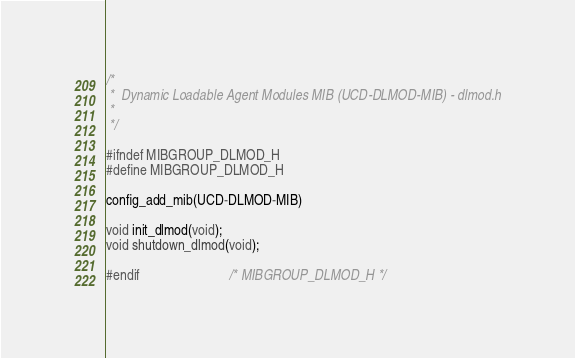Convert code to text. <code><loc_0><loc_0><loc_500><loc_500><_C_>/*
 *  Dynamic Loadable Agent Modules MIB (UCD-DLMOD-MIB) - dlmod.h
 *
 */

#ifndef MIBGROUP_DLMOD_H
#define MIBGROUP_DLMOD_H

config_add_mib(UCD-DLMOD-MIB)

void init_dlmod(void);
void shutdown_dlmod(void);

#endif                          /* MIBGROUP_DLMOD_H */
</code> 